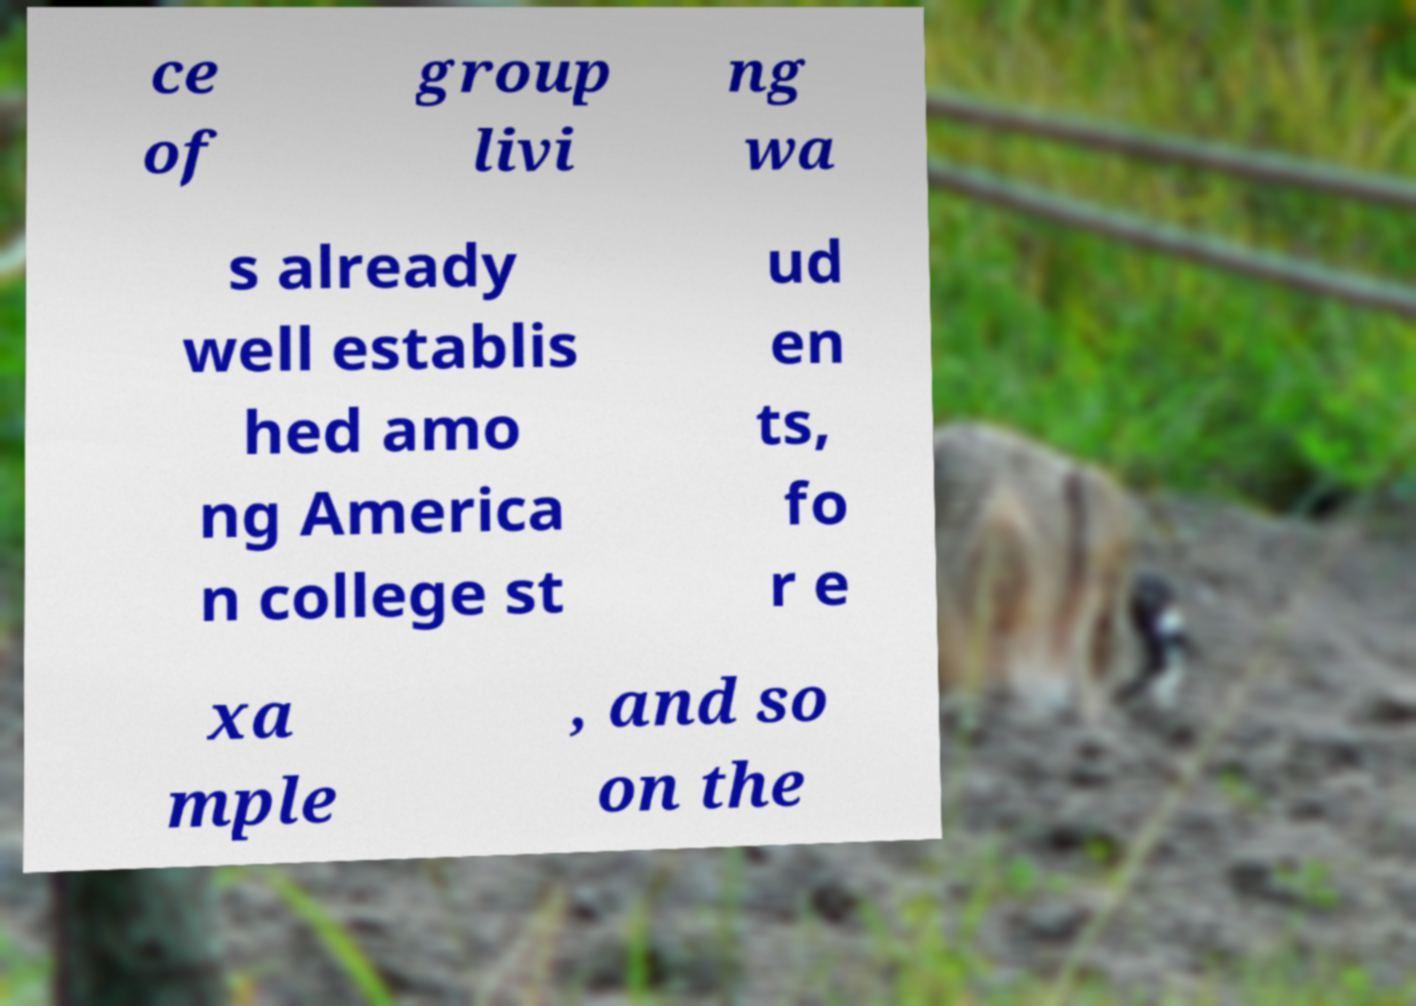There's text embedded in this image that I need extracted. Can you transcribe it verbatim? ce of group livi ng wa s already well establis hed amo ng America n college st ud en ts, fo r e xa mple , and so on the 